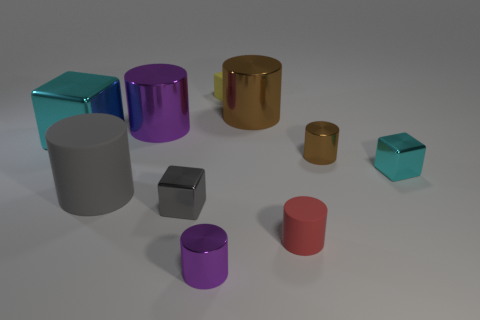Is there any other thing that has the same color as the large matte cylinder?
Your response must be concise. Yes. What is the color of the tiny rubber cylinder?
Keep it short and to the point. Red. Are there any purple metal cylinders?
Offer a very short reply. Yes. There is a large cyan thing; are there any tiny brown things right of it?
Your response must be concise. Yes. There is a tiny yellow thing that is the same shape as the tiny gray metal object; what material is it?
Your answer should be very brief. Rubber. Is there any other thing that has the same material as the tiny gray cube?
Keep it short and to the point. Yes. What number of other things are the same shape as the small brown metallic object?
Offer a very short reply. 5. There is a matte thing on the left side of the purple shiny cylinder that is in front of the large gray matte cylinder; what number of big shiny cylinders are to the left of it?
Offer a very short reply. 0. How many tiny purple objects have the same shape as the small cyan object?
Provide a succinct answer. 0. Is the color of the cube to the right of the tiny brown shiny object the same as the big block?
Offer a very short reply. Yes. 